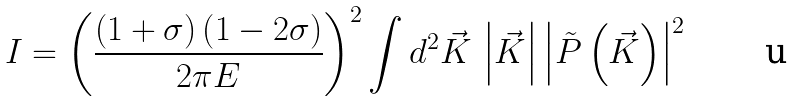Convert formula to latex. <formula><loc_0><loc_0><loc_500><loc_500>I = \left ( \frac { \left ( 1 + \sigma \right ) \left ( 1 - 2 \sigma \right ) } { 2 \pi E } \right ) ^ { 2 } \int d ^ { 2 } \vec { K } \, \left | \vec { K } \right | \left | \tilde { P } \left ( \vec { K } \right ) \right | ^ { 2 }</formula> 